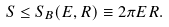<formula> <loc_0><loc_0><loc_500><loc_500>S \leq S _ { B } ( E , R ) \equiv 2 \pi E R .</formula> 